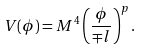Convert formula to latex. <formula><loc_0><loc_0><loc_500><loc_500>V ( \phi ) = M ^ { 4 } \left ( \frac { \phi } { \mp l } \right ) ^ { p } .</formula> 